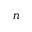Convert formula to latex. <formula><loc_0><loc_0><loc_500><loc_500>n</formula> 